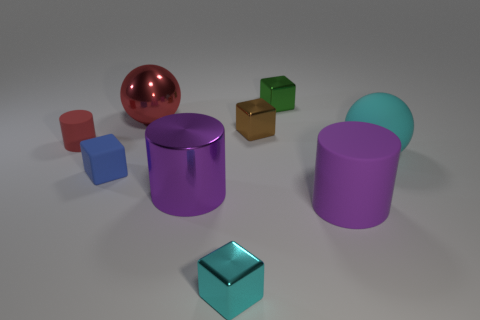What material is the brown block?
Ensure brevity in your answer.  Metal. Are there more tiny blue cubes than large yellow matte objects?
Provide a succinct answer. Yes. Is the shape of the green thing the same as the red metallic object?
Your answer should be compact. No. Is there any other thing that has the same shape as the large red metal thing?
Give a very brief answer. Yes. Does the cylinder that is on the left side of the metallic ball have the same color as the rubber sphere behind the tiny cyan block?
Provide a succinct answer. No. Is the number of large matte balls in front of the big cyan rubber thing less than the number of small blue blocks that are in front of the blue block?
Provide a succinct answer. No. There is a red thing that is on the left side of the shiny sphere; what is its shape?
Provide a short and direct response. Cylinder. What is the material of the tiny thing that is the same color as the large rubber ball?
Your answer should be very brief. Metal. How many other objects are there of the same material as the tiny red cylinder?
Offer a terse response. 3. There is a tiny brown shiny object; is its shape the same as the red thing in front of the red metal thing?
Make the answer very short. No. 